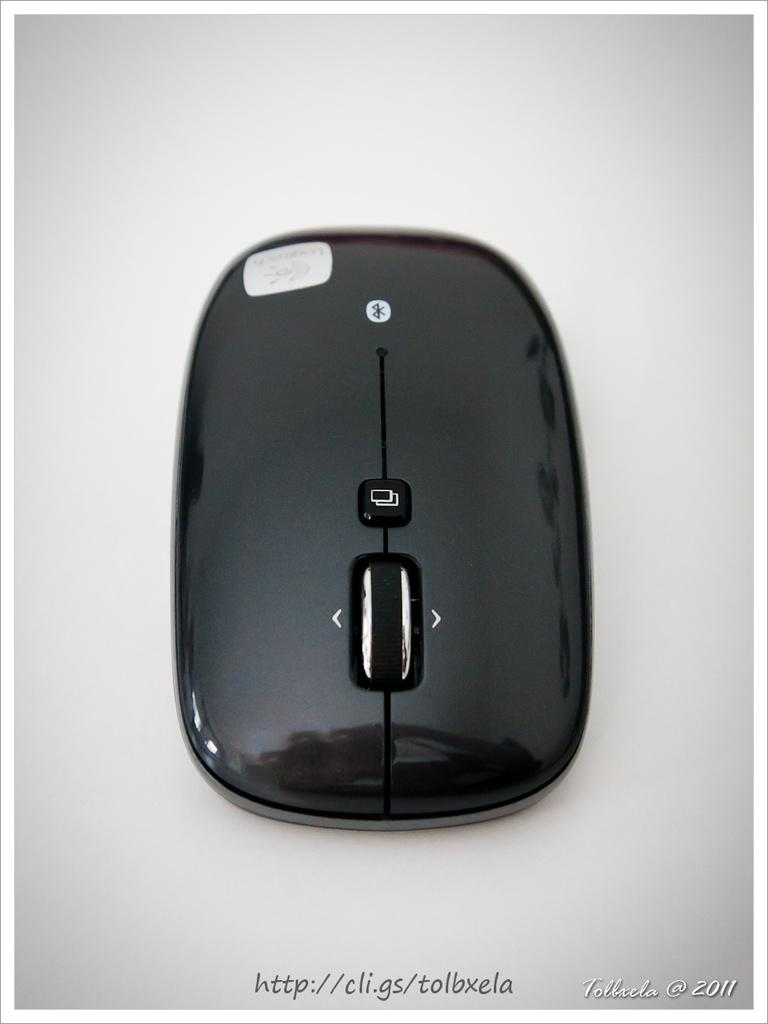<image>
Summarize the visual content of the image. A wirless mouse image with a date of 2011 at the bottom of the image. 